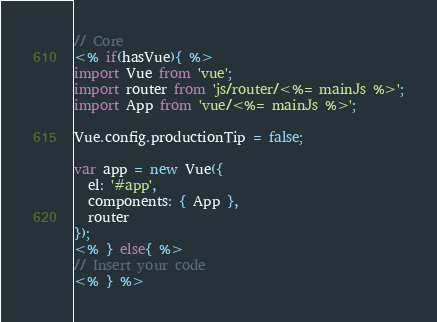Convert code to text. <code><loc_0><loc_0><loc_500><loc_500><_JavaScript_>// Core
<% if(hasVue){ %>
import Vue from 'vue';
import router from 'js/router/<%= mainJs %>';
import App from 'vue/<%= mainJs %>';

Vue.config.productionTip = false;

var app = new Vue({
  el: '#app',
  components: { App },
  router
});
<% } else{ %>
// Insert your code
<% } %></code> 